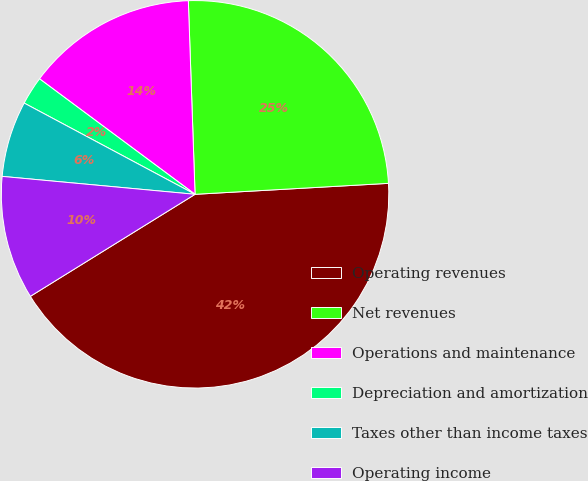Convert chart. <chart><loc_0><loc_0><loc_500><loc_500><pie_chart><fcel>Operating revenues<fcel>Net revenues<fcel>Operations and maintenance<fcel>Depreciation and amortization<fcel>Taxes other than income taxes<fcel>Operating income<nl><fcel>42.07%<fcel>24.65%<fcel>14.28%<fcel>2.36%<fcel>6.33%<fcel>10.3%<nl></chart> 